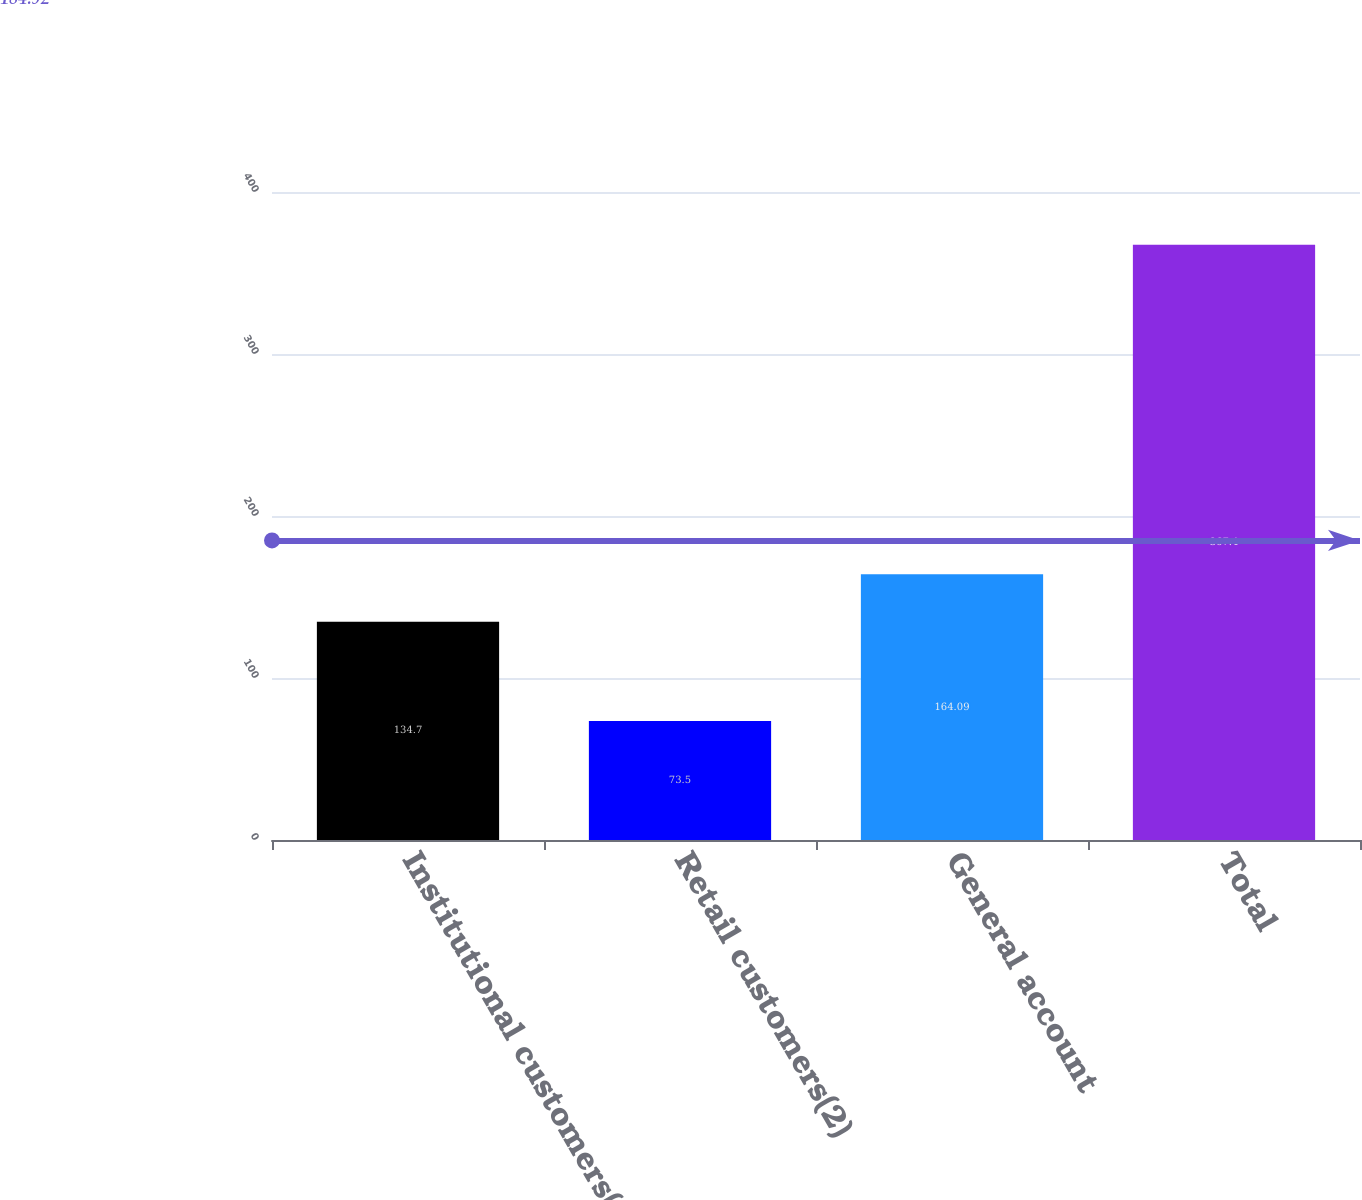Convert chart to OTSL. <chart><loc_0><loc_0><loc_500><loc_500><bar_chart><fcel>Institutional customers(1)<fcel>Retail customers(2)<fcel>General account<fcel>Total<nl><fcel>134.7<fcel>73.5<fcel>164.09<fcel>367.4<nl></chart> 